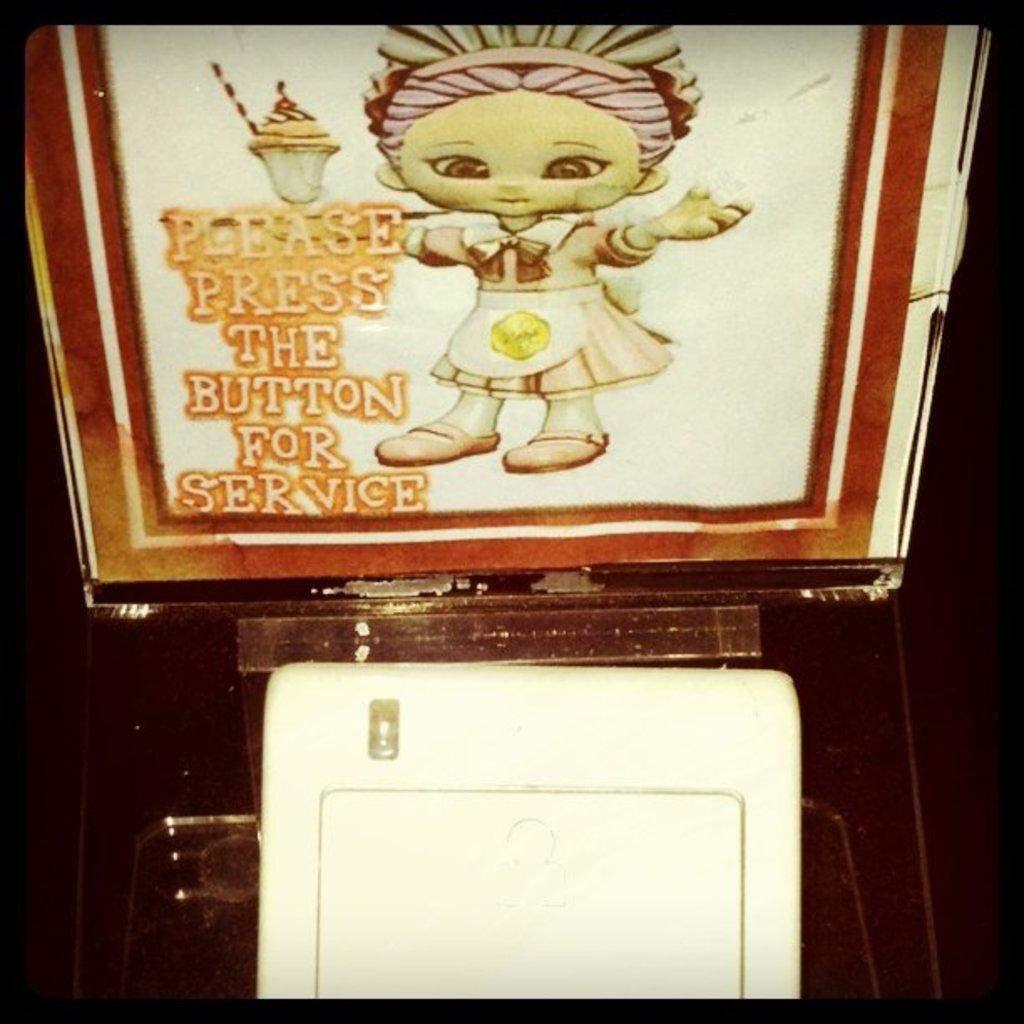How is the poster displayed in the image? The poster is attached to a board. What can be seen in front of the board? There is a white color object placed in front of the board. How is the poster glued to the board in the image? There is no information about how the poster is attached to the board in the image, but it is mentioned that the poster is attached to a board. --- 